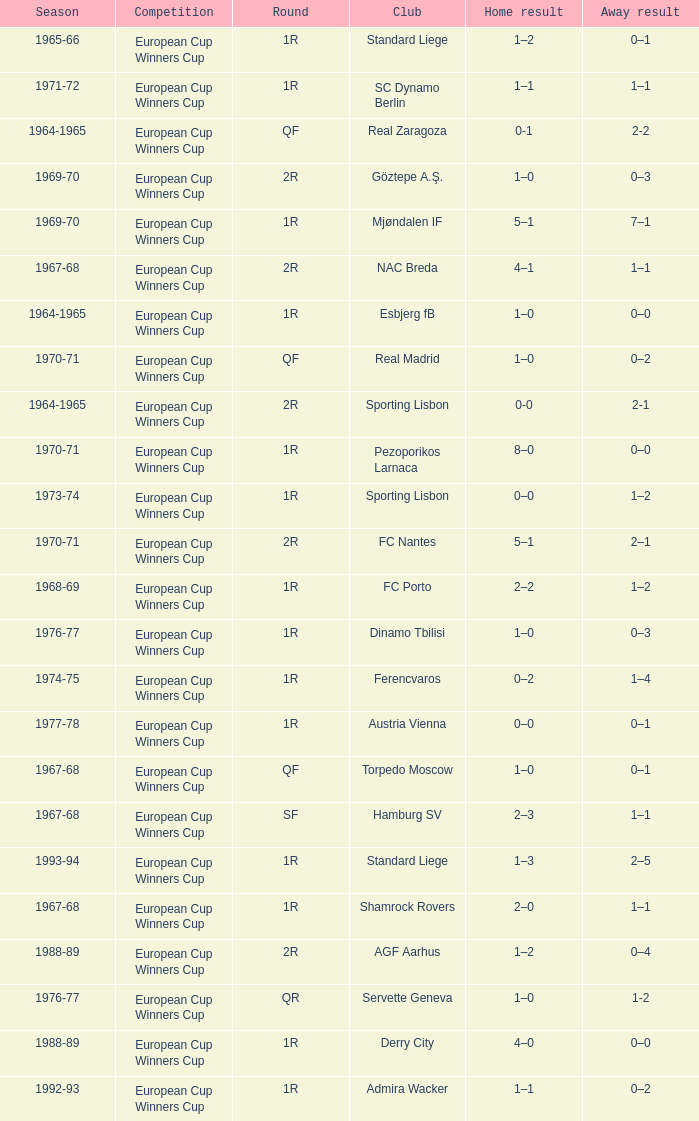Home result of 1–0, and a Away result of 0–1 involves what club? Torpedo Moscow. Give me the full table as a dictionary. {'header': ['Season', 'Competition', 'Round', 'Club', 'Home result', 'Away result'], 'rows': [['1965-66', 'European Cup Winners Cup', '1R', 'Standard Liege', '1–2', '0–1'], ['1971-72', 'European Cup Winners Cup', '1R', 'SC Dynamo Berlin', '1–1', '1–1'], ['1964-1965', 'European Cup Winners Cup', 'QF', 'Real Zaragoza', '0-1', '2-2'], ['1969-70', 'European Cup Winners Cup', '2R', 'Göztepe A.Ş.', '1–0', '0–3'], ['1969-70', 'European Cup Winners Cup', '1R', 'Mjøndalen IF', '5–1', '7–1'], ['1967-68', 'European Cup Winners Cup', '2R', 'NAC Breda', '4–1', '1–1'], ['1964-1965', 'European Cup Winners Cup', '1R', 'Esbjerg fB', '1–0', '0–0'], ['1970-71', 'European Cup Winners Cup', 'QF', 'Real Madrid', '1–0', '0–2'], ['1964-1965', 'European Cup Winners Cup', '2R', 'Sporting Lisbon', '0-0', '2-1'], ['1970-71', 'European Cup Winners Cup', '1R', 'Pezoporikos Larnaca', '8–0', '0–0'], ['1973-74', 'European Cup Winners Cup', '1R', 'Sporting Lisbon', '0–0', '1–2'], ['1970-71', 'European Cup Winners Cup', '2R', 'FC Nantes', '5–1', '2–1'], ['1968-69', 'European Cup Winners Cup', '1R', 'FC Porto', '2–2', '1–2'], ['1976-77', 'European Cup Winners Cup', '1R', 'Dinamo Tbilisi', '1–0', '0–3'], ['1974-75', 'European Cup Winners Cup', '1R', 'Ferencvaros', '0–2', '1–4'], ['1977-78', 'European Cup Winners Cup', '1R', 'Austria Vienna', '0–0', '0–1'], ['1967-68', 'European Cup Winners Cup', 'QF', 'Torpedo Moscow', '1–0', '0–1'], ['1967-68', 'European Cup Winners Cup', 'SF', 'Hamburg SV', '2–3', '1–1'], ['1993-94', 'European Cup Winners Cup', '1R', 'Standard Liege', '1–3', '2–5'], ['1967-68', 'European Cup Winners Cup', '1R', 'Shamrock Rovers', '2–0', '1–1'], ['1988-89', 'European Cup Winners Cup', '2R', 'AGF Aarhus', '1–2', '0–4'], ['1976-77', 'European Cup Winners Cup', 'QR', 'Servette Geneva', '1–0', '1-2'], ['1988-89', 'European Cup Winners Cup', '1R', 'Derry City', '4–0', '0–0'], ['1992-93', 'European Cup Winners Cup', '1R', 'Admira Wacker', '1–1', '0–2']]} 